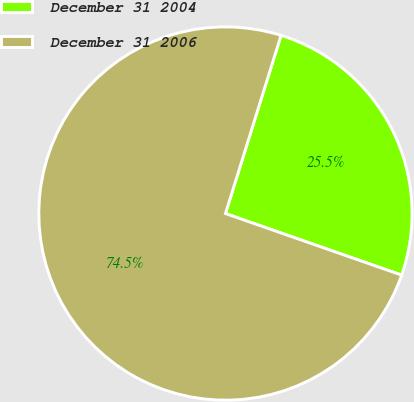Convert chart. <chart><loc_0><loc_0><loc_500><loc_500><pie_chart><fcel>December 31 2004<fcel>December 31 2006<nl><fcel>25.54%<fcel>74.46%<nl></chart> 